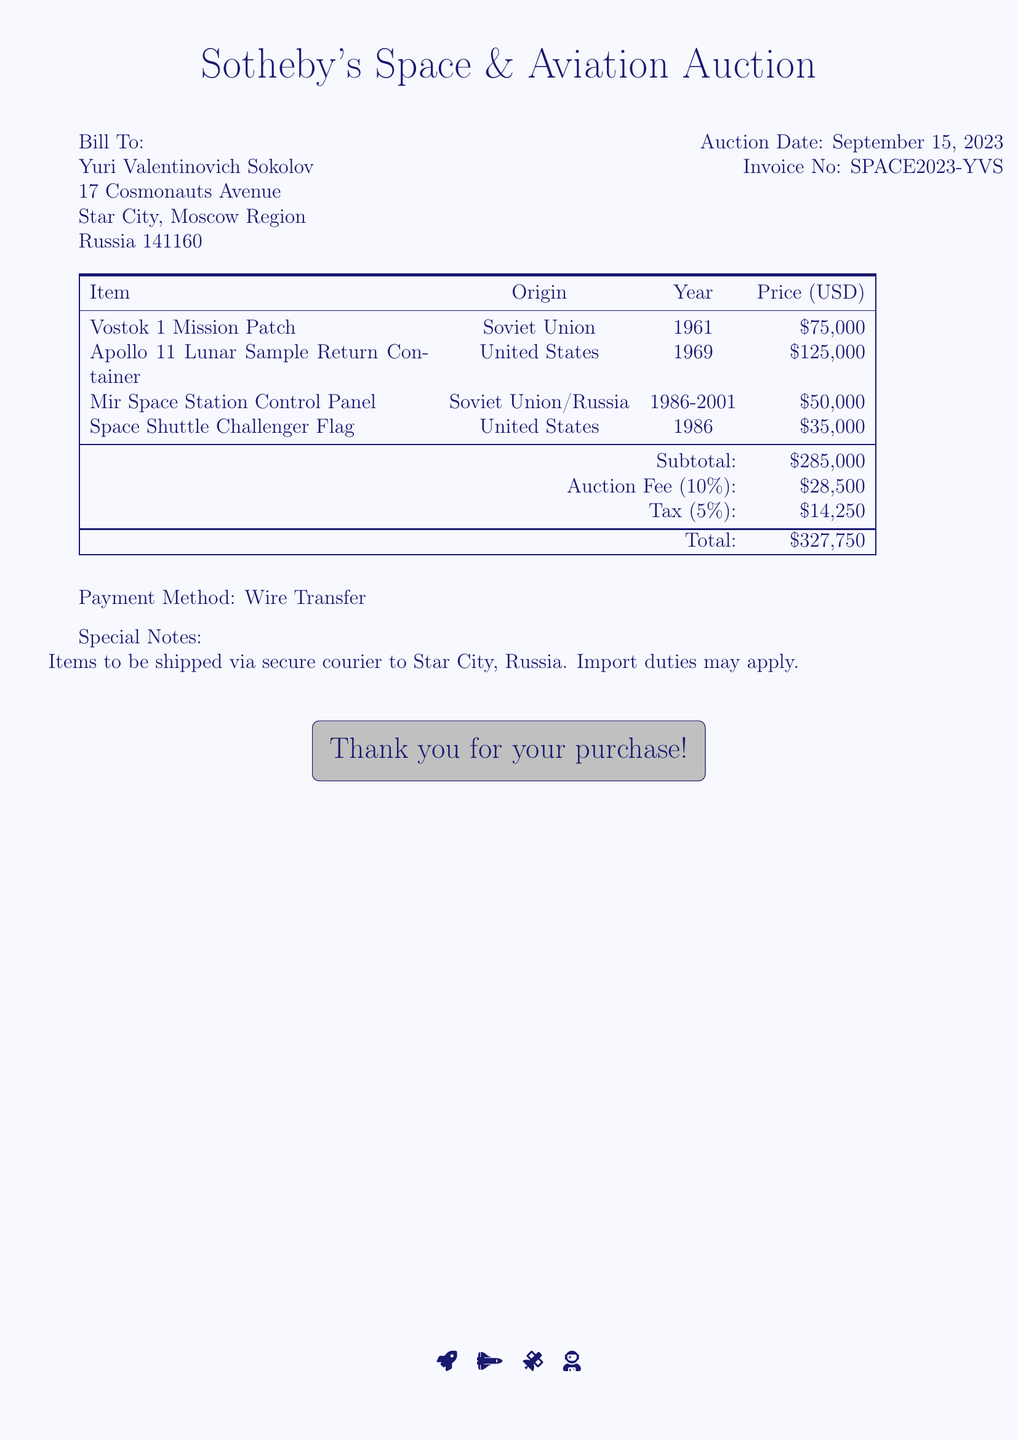what is the total amount due? The total amount due is the sum of the subtotal, auction fee, and tax listed in the document, which totals to $327,750.
Answer: $327,750 who is the bill addressed to? The bill is addressed to Yuri Valentinovich Sokolov, as shown in the document.
Answer: Yuri Valentinovich Sokolov what is the auction fee percentage? The auction fee is calculated at 10% of the subtotal, which is stated in the document.
Answer: 10% how many rare items are listed in the document? The document lists four rare items, each with their respective details.
Answer: 4 what is the origin of the Apollo 11 item? The origin of the Apollo 11 Lunar Sample Return Container is specified in the document as the United States.
Answer: United States which payment method is specified? The payment method indicated in the document is a wire transfer.
Answer: Wire Transfer what year was the Mir Space Station Control Panel in use? The use period for the Mir Space Station Control Panel is indicated as 1986-2001 in the document.
Answer: 1986-2001 what shipping method will be used for the items? The document specifies that the items will be shipped via secure courier.
Answer: secure courier 